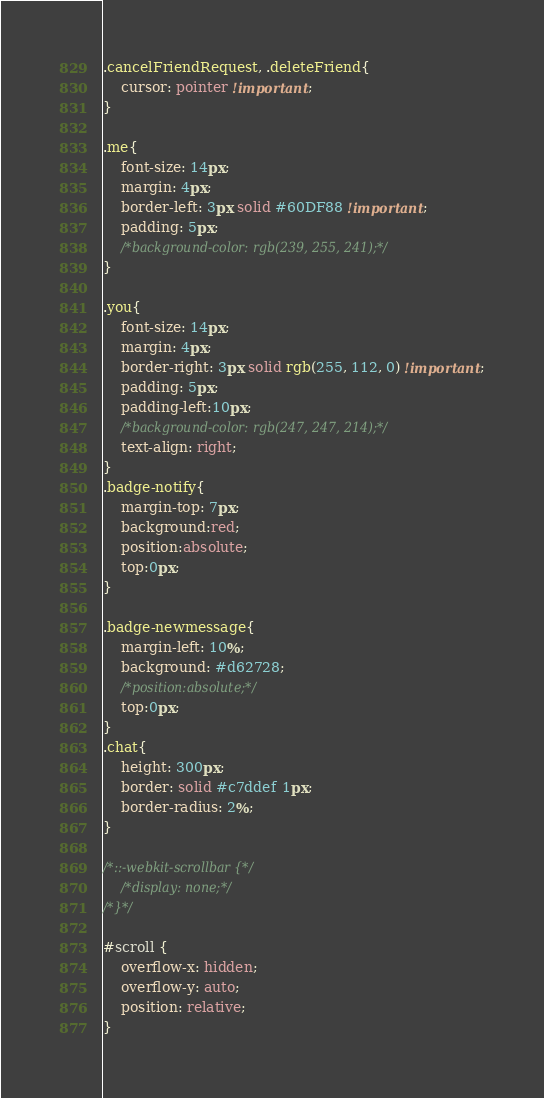<code> <loc_0><loc_0><loc_500><loc_500><_CSS_>.cancelFriendRequest, .deleteFriend{
    cursor: pointer !important;
}

.me{
    font-size: 14px;
    margin: 4px;
    border-left: 3px solid #60DF88 !important;
    padding: 5px;
    /*background-color: rgb(239, 255, 241);*/
}

.you{
    font-size: 14px;
    margin: 4px;
    border-right: 3px solid rgb(255, 112, 0) !important;
    padding: 5px;
    padding-left:10px;
    /*background-color: rgb(247, 247, 214);*/
    text-align: right;
}
.badge-notify{
    margin-top: 7px;
    background:red;
    position:absolute;
    top:0px;
}

.badge-newmessage{
    margin-left: 10%;
    background: #d62728;
    /*position:absolute;*/
    top:0px;
}
.chat{
    height: 300px;
    border: solid #c7ddef 1px;
    border-radius: 2%;
}

/*::-webkit-scrollbar {*/
    /*display: none;*/
/*}*/

#scroll {
    overflow-x: hidden;
    overflow-y: auto;
    position: relative;
}</code> 